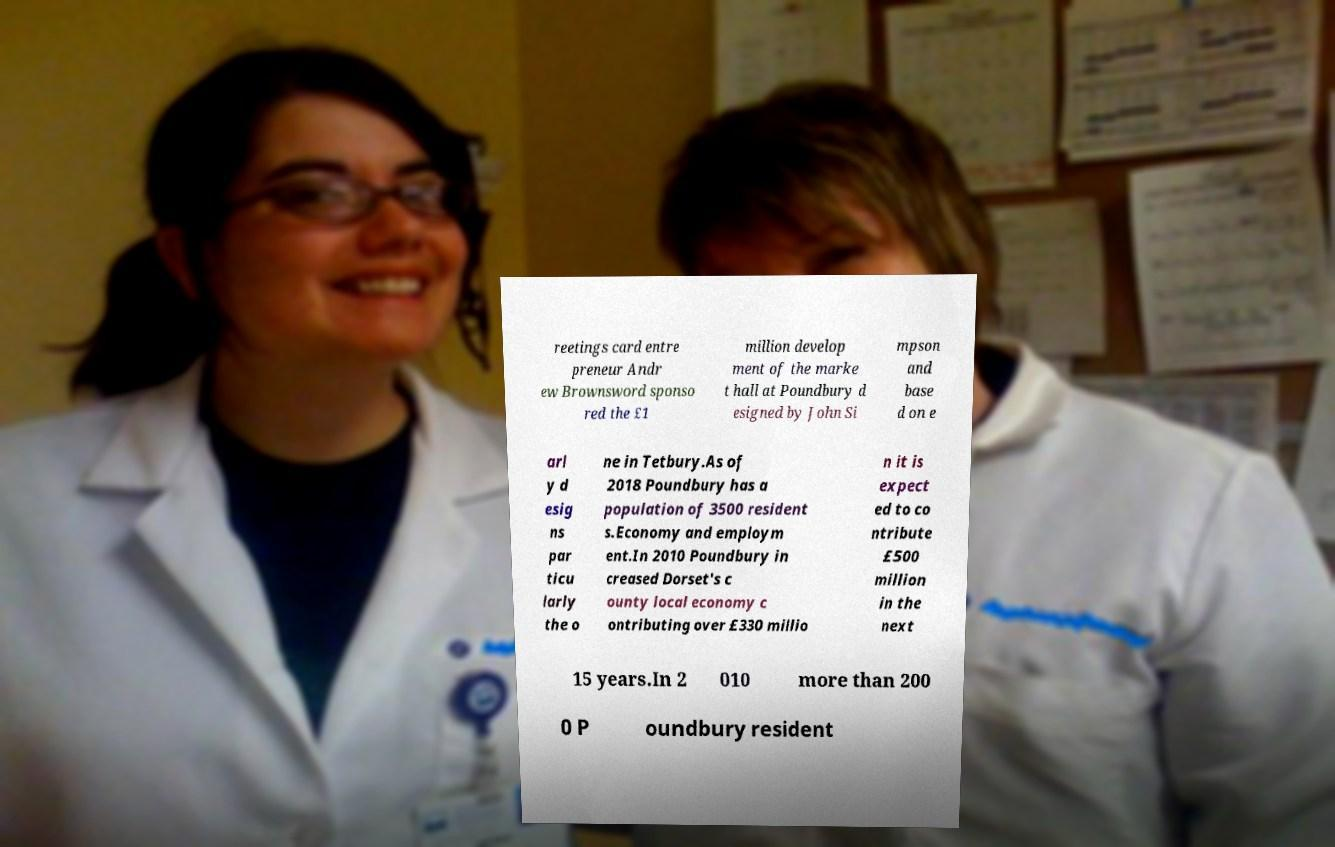Could you assist in decoding the text presented in this image and type it out clearly? reetings card entre preneur Andr ew Brownsword sponso red the £1 million develop ment of the marke t hall at Poundbury d esigned by John Si mpson and base d on e arl y d esig ns par ticu larly the o ne in Tetbury.As of 2018 Poundbury has a population of 3500 resident s.Economy and employm ent.In 2010 Poundbury in creased Dorset's c ounty local economy c ontributing over £330 millio n it is expect ed to co ntribute £500 million in the next 15 years.In 2 010 more than 200 0 P oundbury resident 